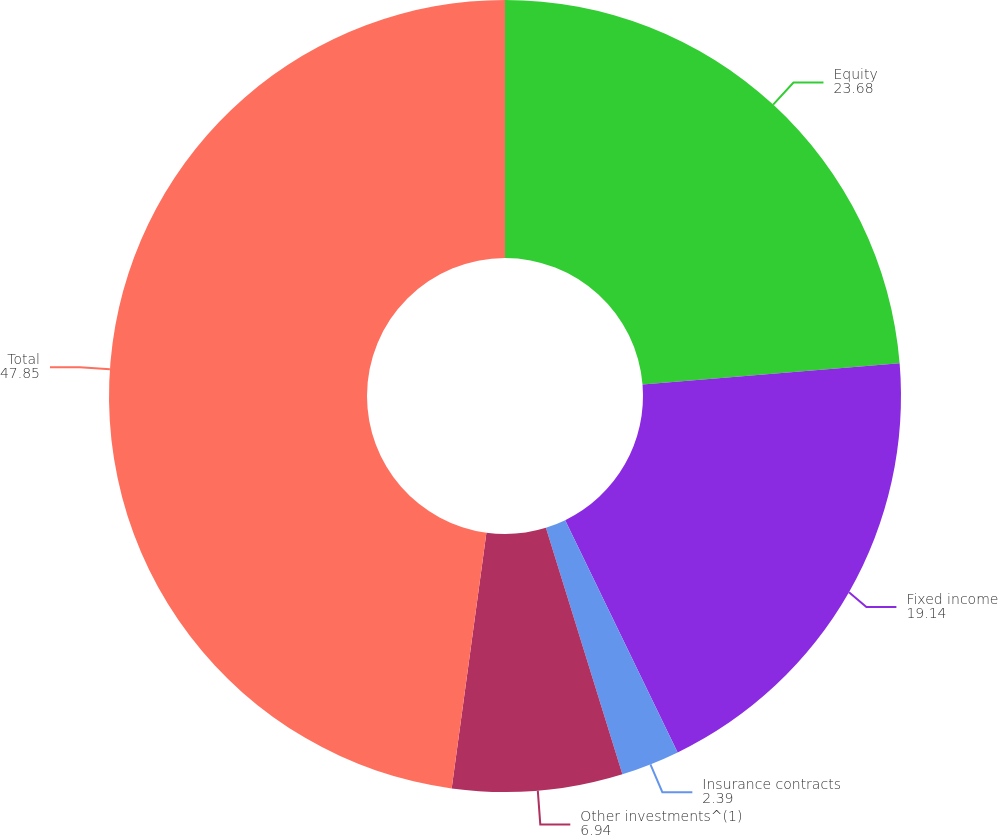Convert chart. <chart><loc_0><loc_0><loc_500><loc_500><pie_chart><fcel>Equity<fcel>Fixed income<fcel>Insurance contracts<fcel>Other investments^(1)<fcel>Total<nl><fcel>23.68%<fcel>19.14%<fcel>2.39%<fcel>6.94%<fcel>47.85%<nl></chart> 